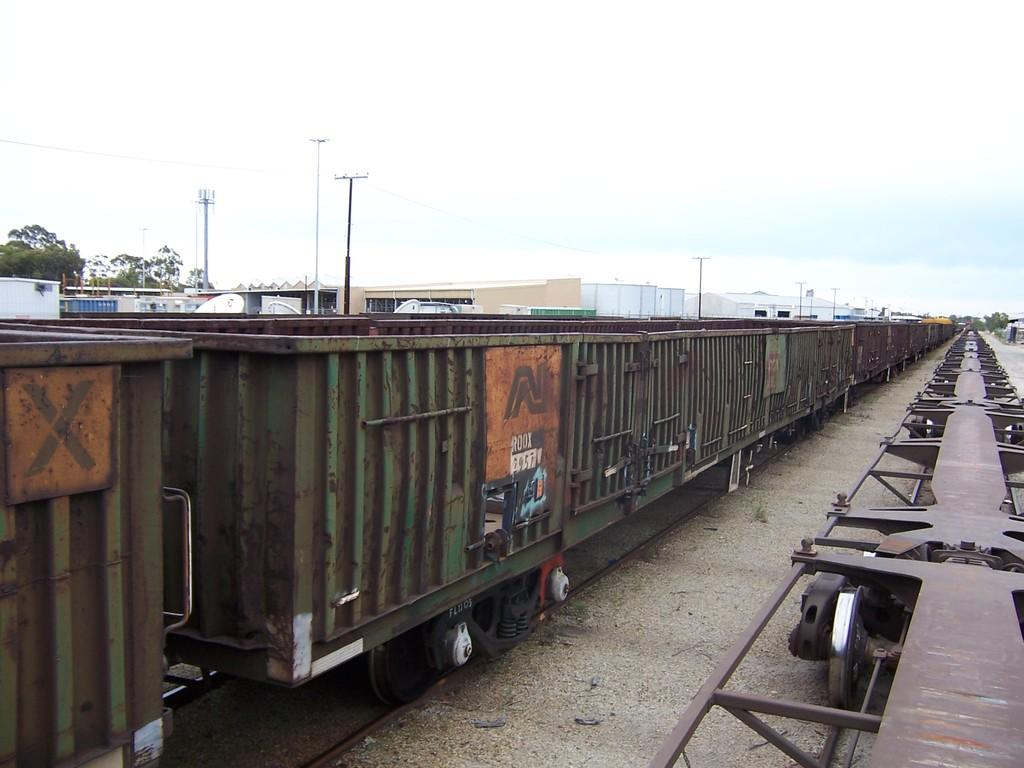What type of train is in the image? There is a goods train in the image. Where is the train located? The train is standing on railway tracks. What can be seen in the background of the image? There are buildings and trees visible in the background of the image. What type of cart is being used to deliver the news in the image? There is no cart or news delivery in the image; it features a goods train standing on railway tracks with buildings and trees in the background. 